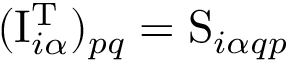Convert formula to latex. <formula><loc_0><loc_0><loc_500><loc_500>( I _ { i \alpha } ^ { T } ) _ { p q } = S _ { i \alpha q p }</formula> 